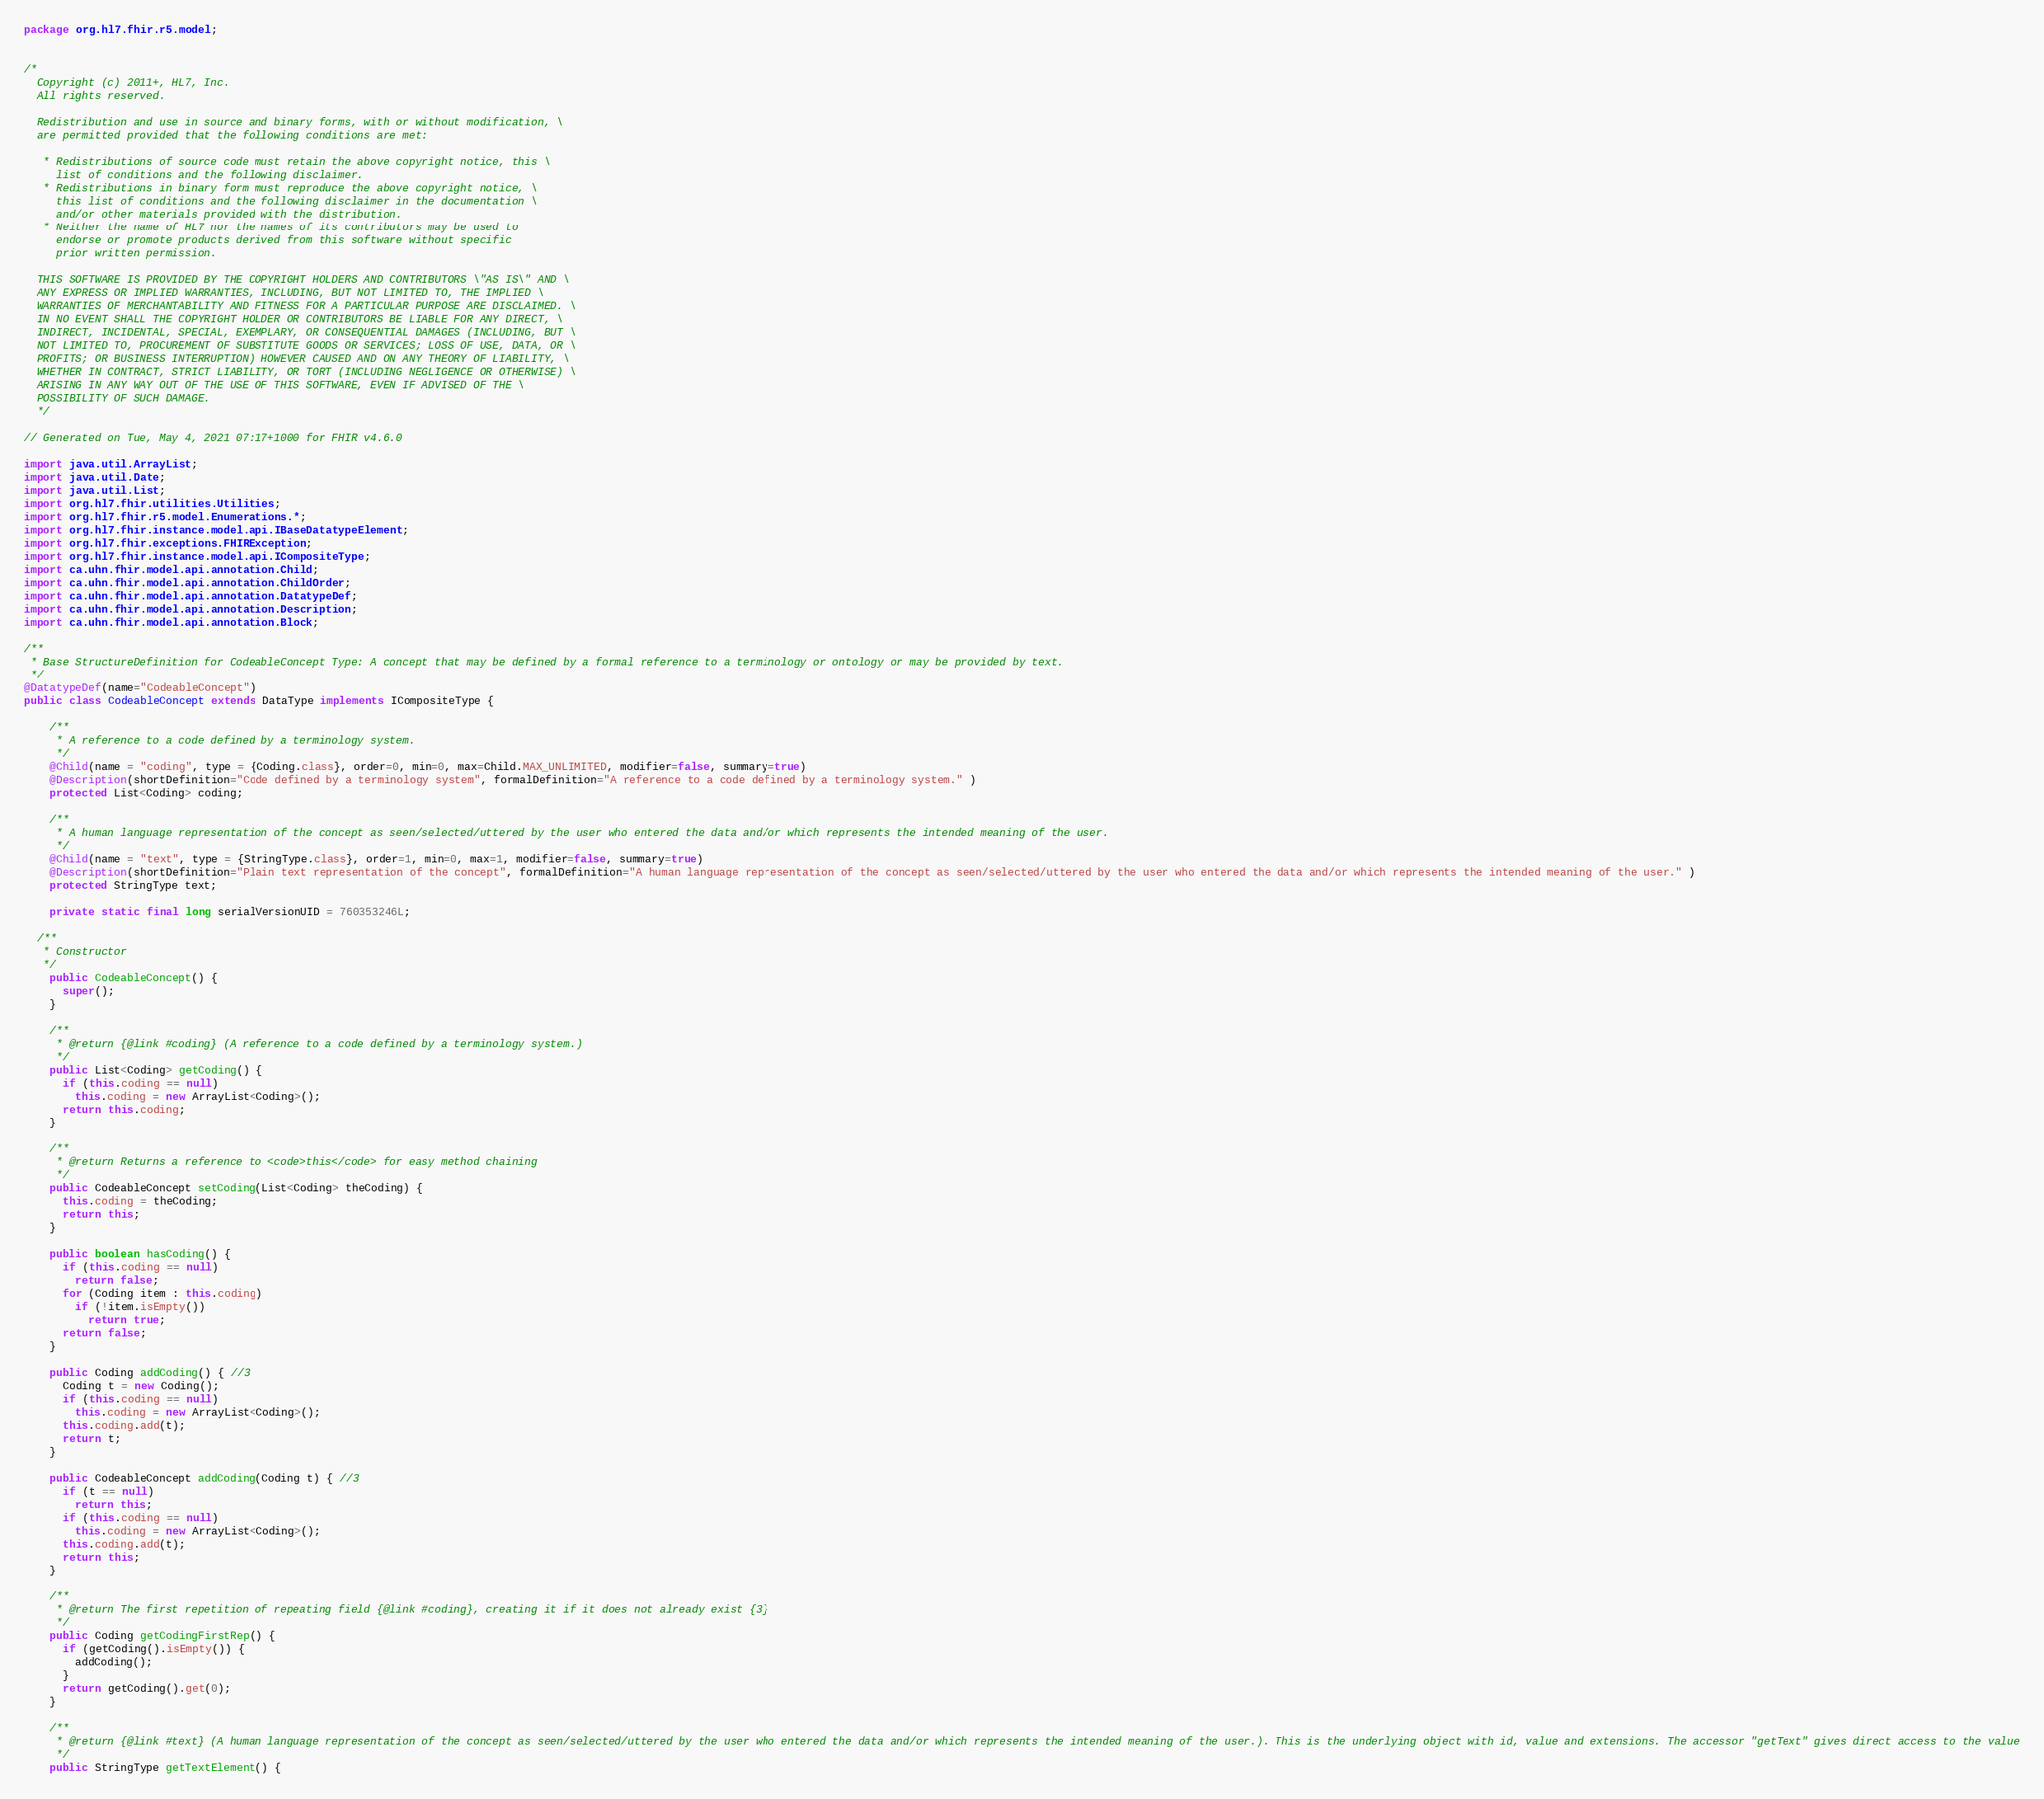<code> <loc_0><loc_0><loc_500><loc_500><_Java_>package org.hl7.fhir.r5.model;


/*
  Copyright (c) 2011+, HL7, Inc.
  All rights reserved.
  
  Redistribution and use in source and binary forms, with or without modification, \
  are permitted provided that the following conditions are met:
  
   * Redistributions of source code must retain the above copyright notice, this \
     list of conditions and the following disclaimer.
   * Redistributions in binary form must reproduce the above copyright notice, \
     this list of conditions and the following disclaimer in the documentation \
     and/or other materials provided with the distribution.
   * Neither the name of HL7 nor the names of its contributors may be used to 
     endorse or promote products derived from this software without specific 
     prior written permission.
  
  THIS SOFTWARE IS PROVIDED BY THE COPYRIGHT HOLDERS AND CONTRIBUTORS \"AS IS\" AND \
  ANY EXPRESS OR IMPLIED WARRANTIES, INCLUDING, BUT NOT LIMITED TO, THE IMPLIED \
  WARRANTIES OF MERCHANTABILITY AND FITNESS FOR A PARTICULAR PURPOSE ARE DISCLAIMED. \
  IN NO EVENT SHALL THE COPYRIGHT HOLDER OR CONTRIBUTORS BE LIABLE FOR ANY DIRECT, \
  INDIRECT, INCIDENTAL, SPECIAL, EXEMPLARY, OR CONSEQUENTIAL DAMAGES (INCLUDING, BUT \
  NOT LIMITED TO, PROCUREMENT OF SUBSTITUTE GOODS OR SERVICES; LOSS OF USE, DATA, OR \
  PROFITS; OR BUSINESS INTERRUPTION) HOWEVER CAUSED AND ON ANY THEORY OF LIABILITY, \
  WHETHER IN CONTRACT, STRICT LIABILITY, OR TORT (INCLUDING NEGLIGENCE OR OTHERWISE) \
  ARISING IN ANY WAY OUT OF THE USE OF THIS SOFTWARE, EVEN IF ADVISED OF THE \
  POSSIBILITY OF SUCH DAMAGE.
  */

// Generated on Tue, May 4, 2021 07:17+1000 for FHIR v4.6.0

import java.util.ArrayList;
import java.util.Date;
import java.util.List;
import org.hl7.fhir.utilities.Utilities;
import org.hl7.fhir.r5.model.Enumerations.*;
import org.hl7.fhir.instance.model.api.IBaseDatatypeElement;
import org.hl7.fhir.exceptions.FHIRException;
import org.hl7.fhir.instance.model.api.ICompositeType;
import ca.uhn.fhir.model.api.annotation.Child;
import ca.uhn.fhir.model.api.annotation.ChildOrder;
import ca.uhn.fhir.model.api.annotation.DatatypeDef;
import ca.uhn.fhir.model.api.annotation.Description;
import ca.uhn.fhir.model.api.annotation.Block;

/**
 * Base StructureDefinition for CodeableConcept Type: A concept that may be defined by a formal reference to a terminology or ontology or may be provided by text.
 */
@DatatypeDef(name="CodeableConcept")
public class CodeableConcept extends DataType implements ICompositeType {

    /**
     * A reference to a code defined by a terminology system.
     */
    @Child(name = "coding", type = {Coding.class}, order=0, min=0, max=Child.MAX_UNLIMITED, modifier=false, summary=true)
    @Description(shortDefinition="Code defined by a terminology system", formalDefinition="A reference to a code defined by a terminology system." )
    protected List<Coding> coding;

    /**
     * A human language representation of the concept as seen/selected/uttered by the user who entered the data and/or which represents the intended meaning of the user.
     */
    @Child(name = "text", type = {StringType.class}, order=1, min=0, max=1, modifier=false, summary=true)
    @Description(shortDefinition="Plain text representation of the concept", formalDefinition="A human language representation of the concept as seen/selected/uttered by the user who entered the data and/or which represents the intended meaning of the user." )
    protected StringType text;

    private static final long serialVersionUID = 760353246L;

  /**
   * Constructor
   */
    public CodeableConcept() {
      super();
    }

    /**
     * @return {@link #coding} (A reference to a code defined by a terminology system.)
     */
    public List<Coding> getCoding() { 
      if (this.coding == null)
        this.coding = new ArrayList<Coding>();
      return this.coding;
    }

    /**
     * @return Returns a reference to <code>this</code> for easy method chaining
     */
    public CodeableConcept setCoding(List<Coding> theCoding) { 
      this.coding = theCoding;
      return this;
    }

    public boolean hasCoding() { 
      if (this.coding == null)
        return false;
      for (Coding item : this.coding)
        if (!item.isEmpty())
          return true;
      return false;
    }

    public Coding addCoding() { //3
      Coding t = new Coding();
      if (this.coding == null)
        this.coding = new ArrayList<Coding>();
      this.coding.add(t);
      return t;
    }

    public CodeableConcept addCoding(Coding t) { //3
      if (t == null)
        return this;
      if (this.coding == null)
        this.coding = new ArrayList<Coding>();
      this.coding.add(t);
      return this;
    }

    /**
     * @return The first repetition of repeating field {@link #coding}, creating it if it does not already exist {3}
     */
    public Coding getCodingFirstRep() { 
      if (getCoding().isEmpty()) {
        addCoding();
      }
      return getCoding().get(0);
    }

    /**
     * @return {@link #text} (A human language representation of the concept as seen/selected/uttered by the user who entered the data and/or which represents the intended meaning of the user.). This is the underlying object with id, value and extensions. The accessor "getText" gives direct access to the value
     */
    public StringType getTextElement() { </code> 